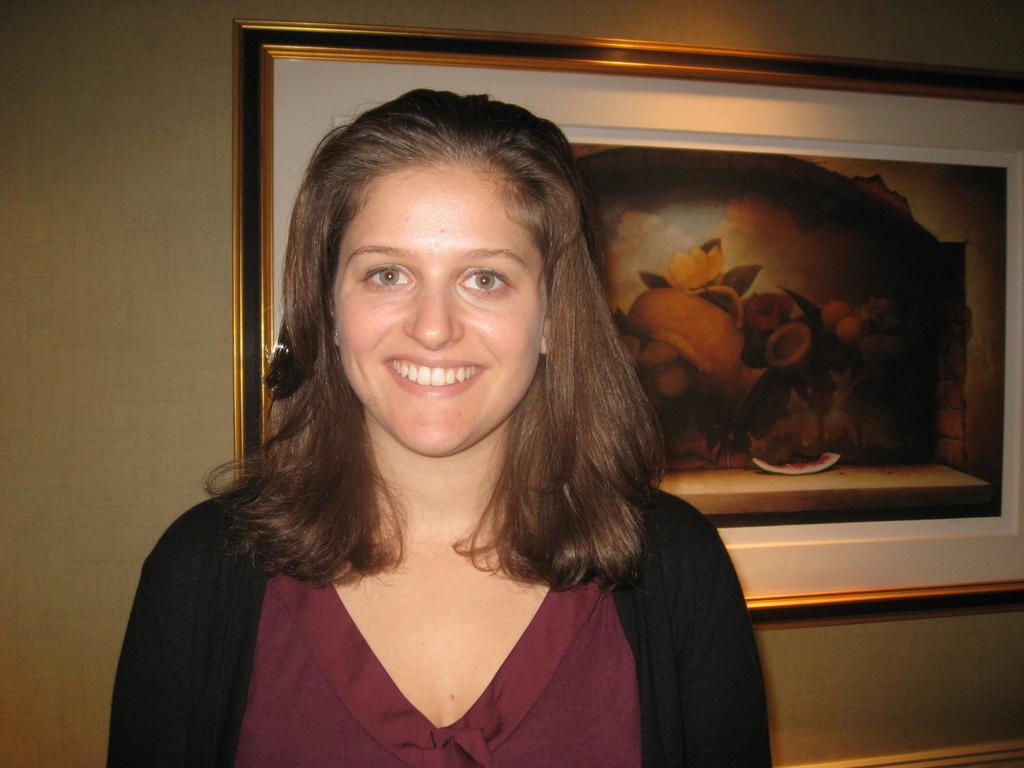Please provide a concise description of this image. In this picture there is a woman smiling. In the background of the image we can see frame on the wall. 